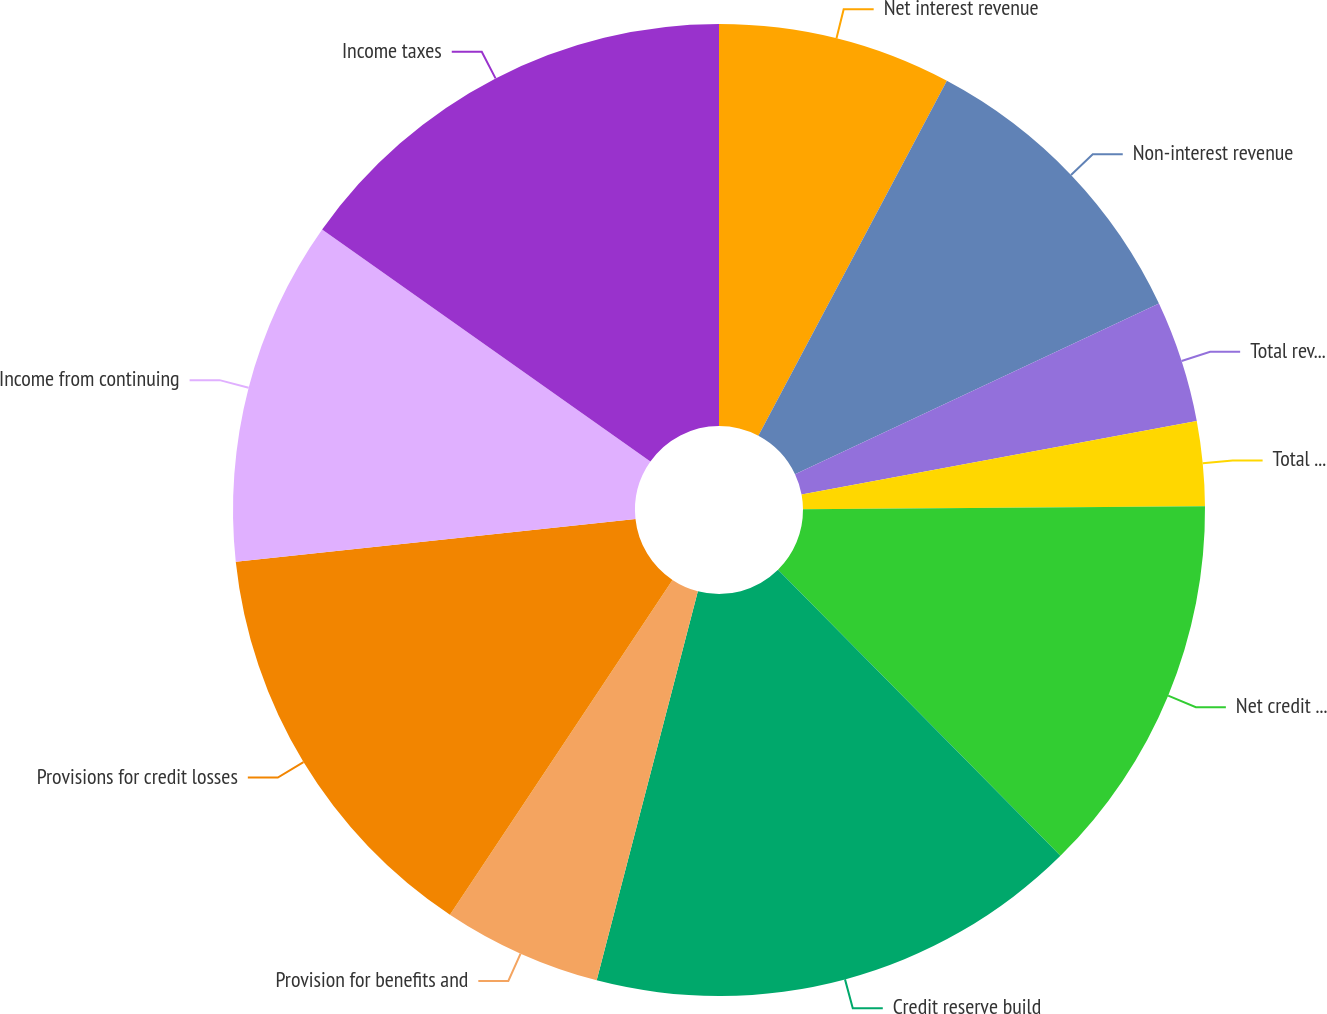Convert chart to OTSL. <chart><loc_0><loc_0><loc_500><loc_500><pie_chart><fcel>Net interest revenue<fcel>Non-interest revenue<fcel>Total revenues net of interest<fcel>Total operating expenses<fcel>Net credit losses<fcel>Credit reserve build<fcel>Provision for benefits and<fcel>Provisions for credit losses<fcel>Income from continuing<fcel>Income taxes<nl><fcel>7.77%<fcel>10.25%<fcel>4.05%<fcel>2.81%<fcel>12.73%<fcel>16.45%<fcel>5.29%<fcel>13.97%<fcel>11.49%<fcel>15.21%<nl></chart> 